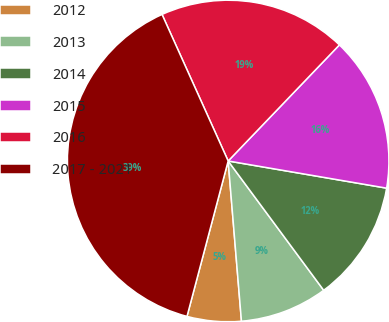Convert chart to OTSL. <chart><loc_0><loc_0><loc_500><loc_500><pie_chart><fcel>2012<fcel>2013<fcel>2014<fcel>2015<fcel>2016<fcel>2017 - 2021<nl><fcel>5.44%<fcel>8.81%<fcel>12.17%<fcel>15.54%<fcel>18.91%<fcel>39.13%<nl></chart> 